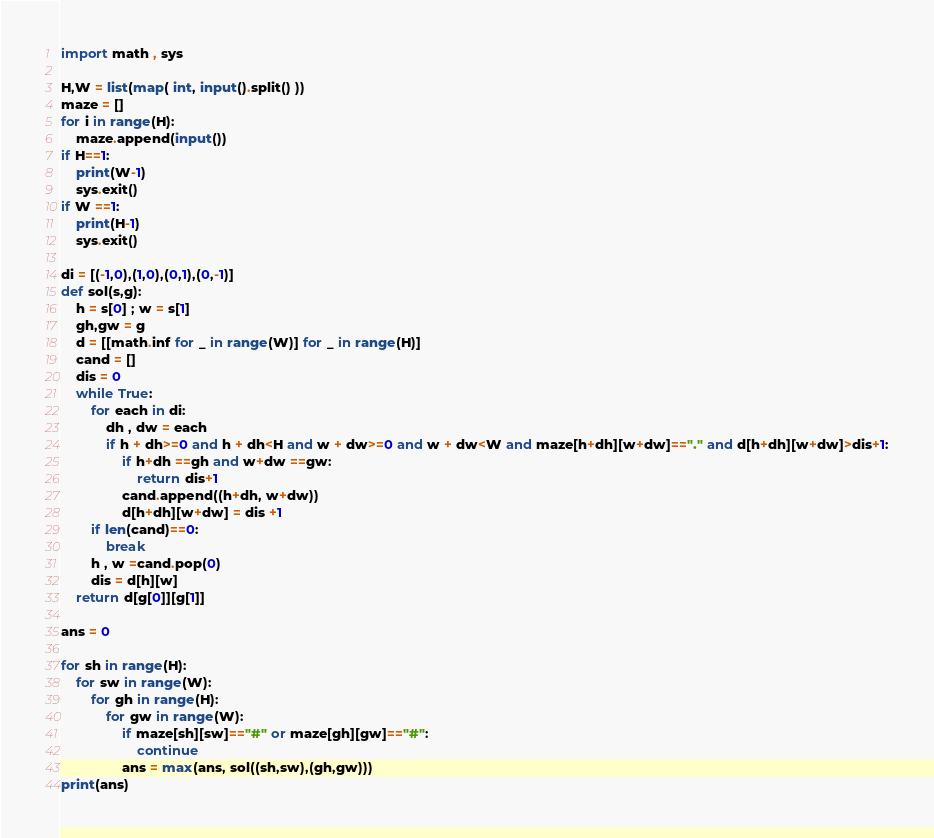Convert code to text. <code><loc_0><loc_0><loc_500><loc_500><_Python_>import math , sys

H,W = list(map( int, input().split() ))
maze = []
for i in range(H):
    maze.append(input())
if H==1:
    print(W-1)
    sys.exit()
if W ==1:
    print(H-1)
    sys.exit()
    
di = [(-1,0),(1,0),(0,1),(0,-1)]
def sol(s,g):
    h = s[0] ; w = s[1]
    gh,gw = g
    d = [[math.inf for _ in range(W)] for _ in range(H)]
    cand = []
    dis = 0
    while True:
        for each in di:
            dh , dw = each
            if h + dh>=0 and h + dh<H and w + dw>=0 and w + dw<W and maze[h+dh][w+dw]=="." and d[h+dh][w+dw]>dis+1:
                if h+dh ==gh and w+dw ==gw:
                    return dis+1
                cand.append((h+dh, w+dw))
                d[h+dh][w+dw] = dis +1
        if len(cand)==0:
            break
        h , w =cand.pop(0)
        dis = d[h][w]
    return d[g[0]][g[1]]

ans = 0

for sh in range(H):
    for sw in range(W):
        for gh in range(H):
            for gw in range(W):
                if maze[sh][sw]=="#" or maze[gh][gw]=="#":
                    continue
                ans = max(ans, sol((sh,sw),(gh,gw)))
print(ans)</code> 